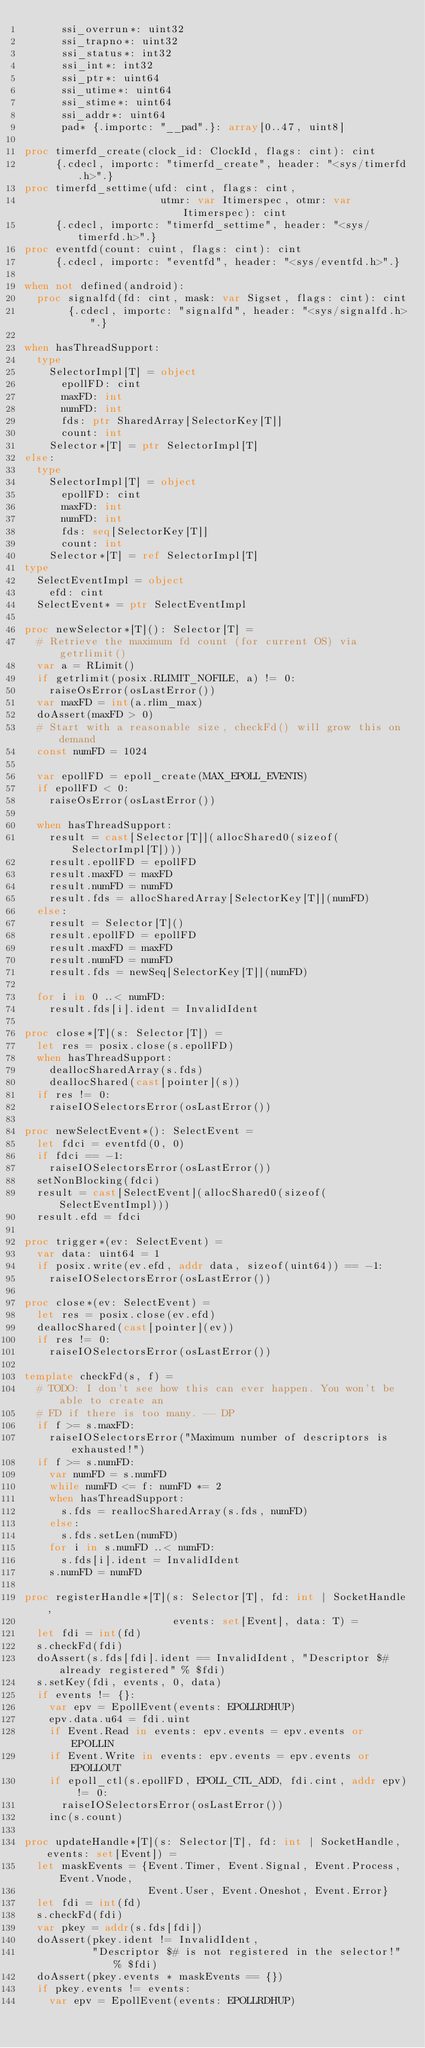Convert code to text. <code><loc_0><loc_0><loc_500><loc_500><_Nim_>      ssi_overrun*: uint32
      ssi_trapno*: uint32
      ssi_status*: int32
      ssi_int*: int32
      ssi_ptr*: uint64
      ssi_utime*: uint64
      ssi_stime*: uint64
      ssi_addr*: uint64
      pad* {.importc: "__pad".}: array[0..47, uint8]

proc timerfd_create(clock_id: ClockId, flags: cint): cint
     {.cdecl, importc: "timerfd_create", header: "<sys/timerfd.h>".}
proc timerfd_settime(ufd: cint, flags: cint,
                      utmr: var Itimerspec, otmr: var Itimerspec): cint
     {.cdecl, importc: "timerfd_settime", header: "<sys/timerfd.h>".}
proc eventfd(count: cuint, flags: cint): cint
     {.cdecl, importc: "eventfd", header: "<sys/eventfd.h>".}

when not defined(android):
  proc signalfd(fd: cint, mask: var Sigset, flags: cint): cint
       {.cdecl, importc: "signalfd", header: "<sys/signalfd.h>".}

when hasThreadSupport:
  type
    SelectorImpl[T] = object
      epollFD: cint
      maxFD: int
      numFD: int
      fds: ptr SharedArray[SelectorKey[T]]
      count: int
    Selector*[T] = ptr SelectorImpl[T]
else:
  type
    SelectorImpl[T] = object
      epollFD: cint
      maxFD: int
      numFD: int
      fds: seq[SelectorKey[T]]
      count: int
    Selector*[T] = ref SelectorImpl[T]
type
  SelectEventImpl = object
    efd: cint
  SelectEvent* = ptr SelectEventImpl

proc newSelector*[T](): Selector[T] =
  # Retrieve the maximum fd count (for current OS) via getrlimit()
  var a = RLimit()
  if getrlimit(posix.RLIMIT_NOFILE, a) != 0:
    raiseOsError(osLastError())
  var maxFD = int(a.rlim_max)
  doAssert(maxFD > 0)
  # Start with a reasonable size, checkFd() will grow this on demand
  const numFD = 1024

  var epollFD = epoll_create(MAX_EPOLL_EVENTS)
  if epollFD < 0:
    raiseOsError(osLastError())

  when hasThreadSupport:
    result = cast[Selector[T]](allocShared0(sizeof(SelectorImpl[T])))
    result.epollFD = epollFD
    result.maxFD = maxFD
    result.numFD = numFD
    result.fds = allocSharedArray[SelectorKey[T]](numFD)
  else:
    result = Selector[T]()
    result.epollFD = epollFD
    result.maxFD = maxFD
    result.numFD = numFD
    result.fds = newSeq[SelectorKey[T]](numFD)

  for i in 0 ..< numFD:
    result.fds[i].ident = InvalidIdent

proc close*[T](s: Selector[T]) =
  let res = posix.close(s.epollFD)
  when hasThreadSupport:
    deallocSharedArray(s.fds)
    deallocShared(cast[pointer](s))
  if res != 0:
    raiseIOSelectorsError(osLastError())

proc newSelectEvent*(): SelectEvent =
  let fdci = eventfd(0, 0)
  if fdci == -1:
    raiseIOSelectorsError(osLastError())
  setNonBlocking(fdci)
  result = cast[SelectEvent](allocShared0(sizeof(SelectEventImpl)))
  result.efd = fdci

proc trigger*(ev: SelectEvent) =
  var data: uint64 = 1
  if posix.write(ev.efd, addr data, sizeof(uint64)) == -1:
    raiseIOSelectorsError(osLastError())

proc close*(ev: SelectEvent) =
  let res = posix.close(ev.efd)
  deallocShared(cast[pointer](ev))
  if res != 0:
    raiseIOSelectorsError(osLastError())

template checkFd(s, f) =
  # TODO: I don't see how this can ever happen. You won't be able to create an
  # FD if there is too many. -- DP
  if f >= s.maxFD:
    raiseIOSelectorsError("Maximum number of descriptors is exhausted!")
  if f >= s.numFD:
    var numFD = s.numFD
    while numFD <= f: numFD *= 2
    when hasThreadSupport:
      s.fds = reallocSharedArray(s.fds, numFD)
    else:
      s.fds.setLen(numFD)
    for i in s.numFD ..< numFD:
      s.fds[i].ident = InvalidIdent
    s.numFD = numFD

proc registerHandle*[T](s: Selector[T], fd: int | SocketHandle,
                        events: set[Event], data: T) =
  let fdi = int(fd)
  s.checkFd(fdi)
  doAssert(s.fds[fdi].ident == InvalidIdent, "Descriptor $# already registered" % $fdi)
  s.setKey(fdi, events, 0, data)
  if events != {}:
    var epv = EpollEvent(events: EPOLLRDHUP)
    epv.data.u64 = fdi.uint
    if Event.Read in events: epv.events = epv.events or EPOLLIN
    if Event.Write in events: epv.events = epv.events or EPOLLOUT
    if epoll_ctl(s.epollFD, EPOLL_CTL_ADD, fdi.cint, addr epv) != 0:
      raiseIOSelectorsError(osLastError())
    inc(s.count)

proc updateHandle*[T](s: Selector[T], fd: int | SocketHandle, events: set[Event]) =
  let maskEvents = {Event.Timer, Event.Signal, Event.Process, Event.Vnode,
                    Event.User, Event.Oneshot, Event.Error}
  let fdi = int(fd)
  s.checkFd(fdi)
  var pkey = addr(s.fds[fdi])
  doAssert(pkey.ident != InvalidIdent,
           "Descriptor $# is not registered in the selector!" % $fdi)
  doAssert(pkey.events * maskEvents == {})
  if pkey.events != events:
    var epv = EpollEvent(events: EPOLLRDHUP)</code> 